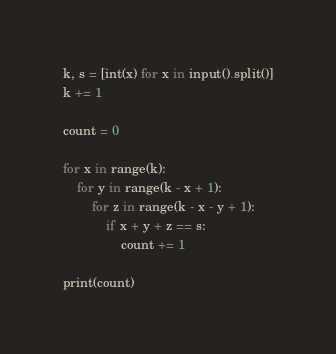<code> <loc_0><loc_0><loc_500><loc_500><_Python_>k, s = [int(x) for x in input().split()]
k += 1

count = 0

for x in range(k):
    for y in range(k - x + 1):
        for z in range(k - x - y + 1):
            if x + y + z == s:
                count += 1

print(count)
</code> 